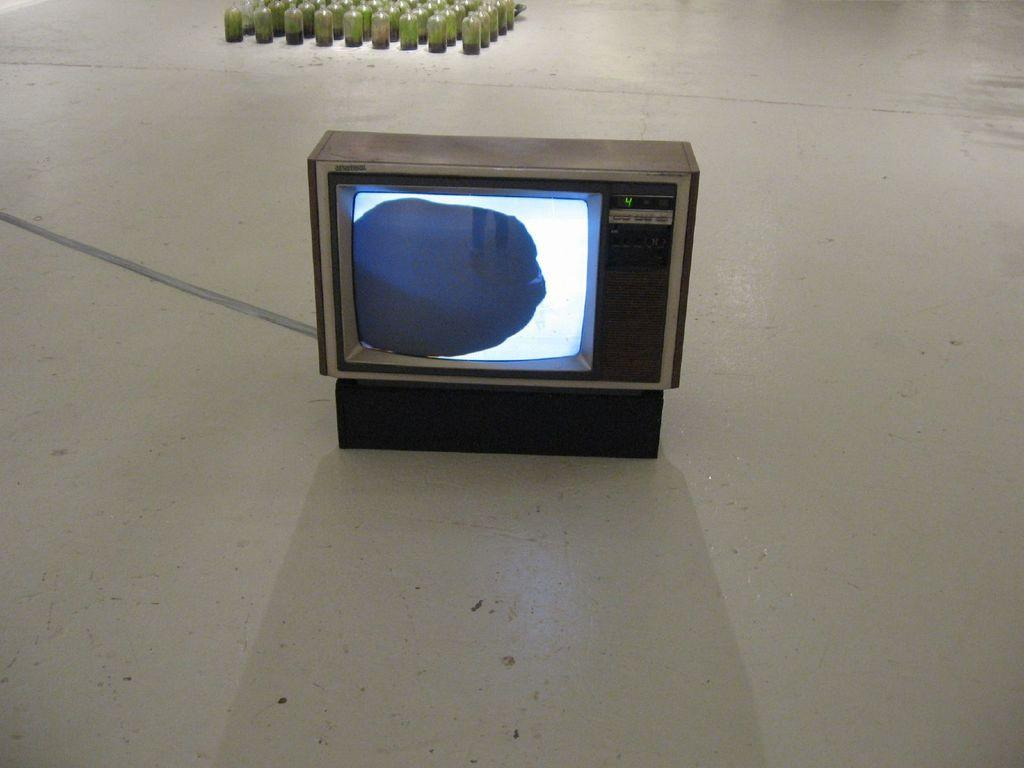<image>
Share a concise interpretation of the image provided. Old box television that is set to channel number 4. 